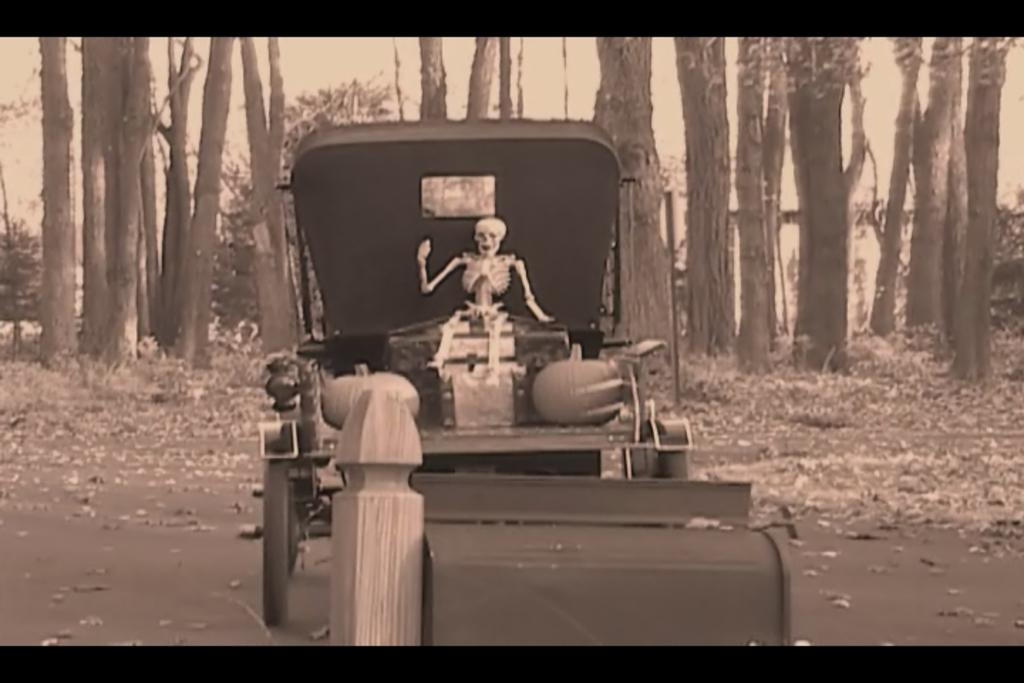What is on the road in the image? There is a vehicle on the road in the image. What can be seen on the vehicle? The vehicle has items on it, including a skeleton. What is the condition of the road in the image? Dry leaves are present on the road. What can be seen in the background of the image? There are many trees in the background of the image. How many passengers are in the vehicle in the image? There is no information about passengers in the image; only a skeleton is mentioned. What type of vest is hanging on the tree in the image? There is no vest or tree present in the image. 